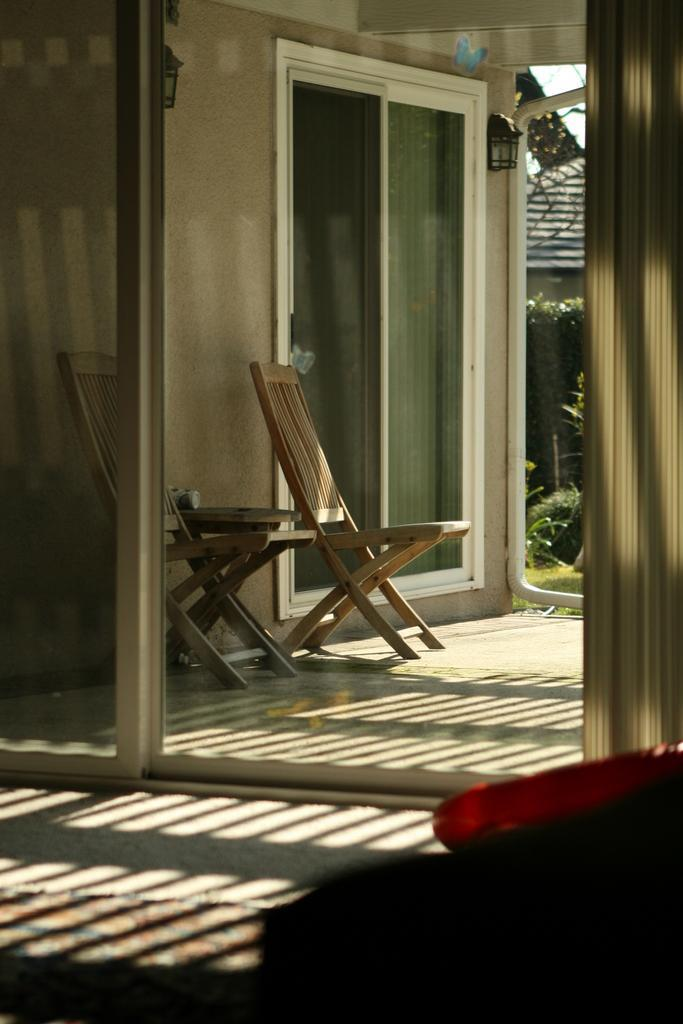What type of door is visible in the image? There is a glass door in the image. What furniture can be seen in the back of the image? There are wooden chairs in the back of the image. Are there any other glass doors in the image? Yes, there are additional glass doors in the image. What is mounted on the wall in the image? There are lights on the wall. What type of vegetation is present in the back of the image? There are plants in the back of the image. Can you see any crates being used as a nest in the image? There is no crate or nest present in the image. 